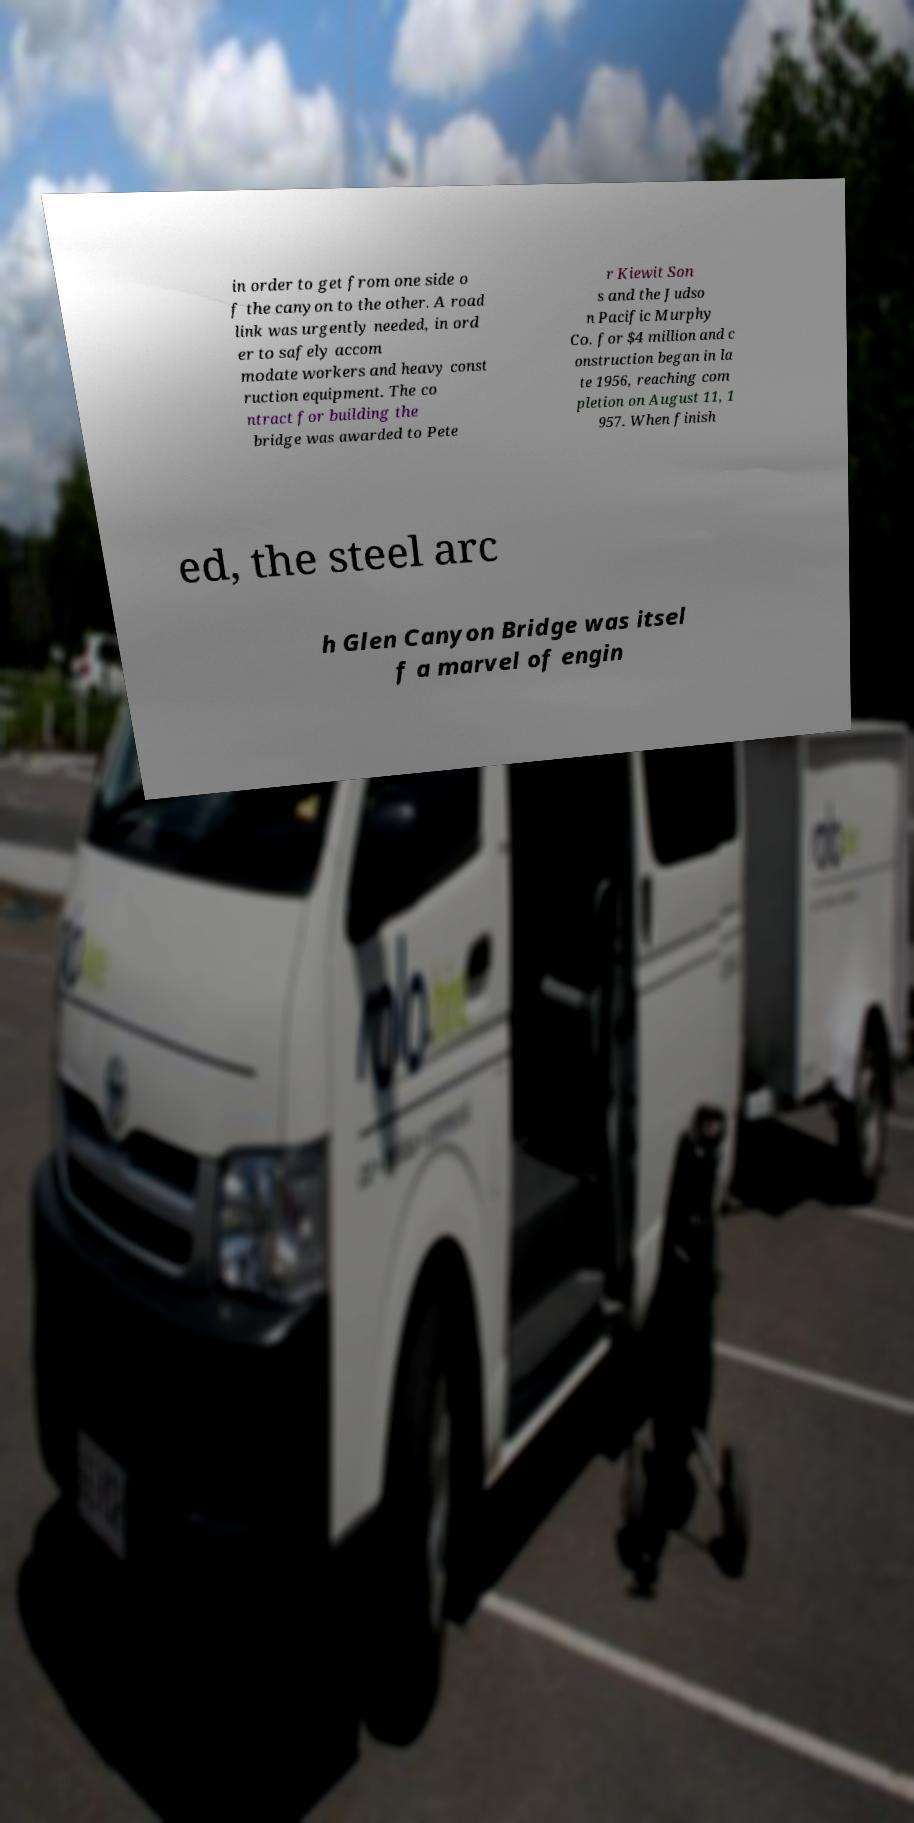Could you extract and type out the text from this image? in order to get from one side o f the canyon to the other. A road link was urgently needed, in ord er to safely accom modate workers and heavy const ruction equipment. The co ntract for building the bridge was awarded to Pete r Kiewit Son s and the Judso n Pacific Murphy Co. for $4 million and c onstruction began in la te 1956, reaching com pletion on August 11, 1 957. When finish ed, the steel arc h Glen Canyon Bridge was itsel f a marvel of engin 